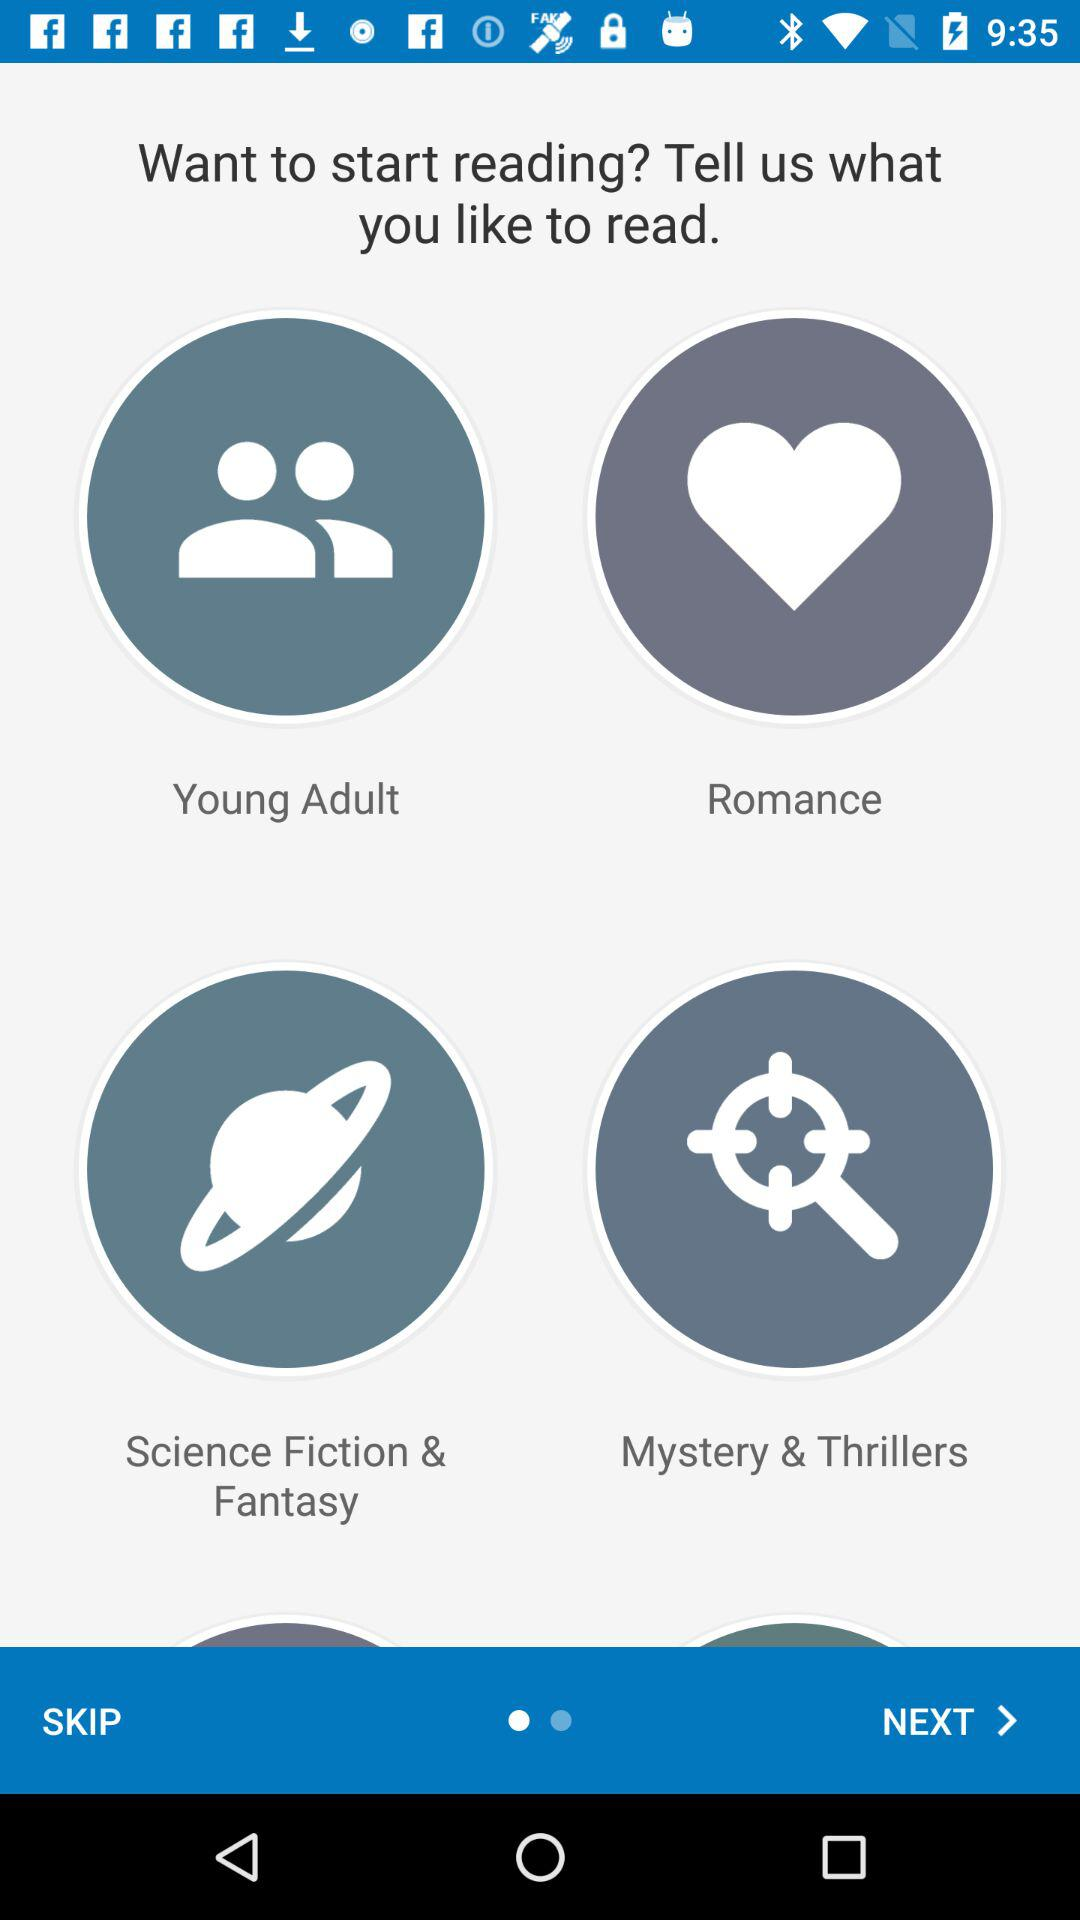What are the available options for reading? The available options are "Young Adult", "Romance", "Science Fiction & Fantasy" and "Mystery & Thrillers". 